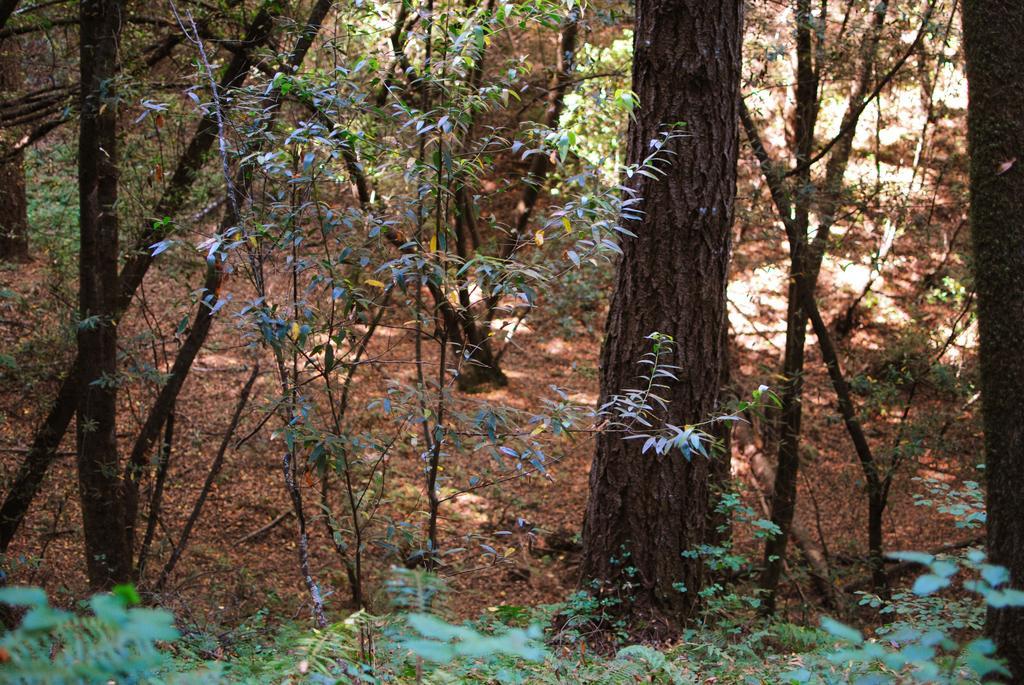Describe this image in one or two sentences. In this image there are trees and plants. 